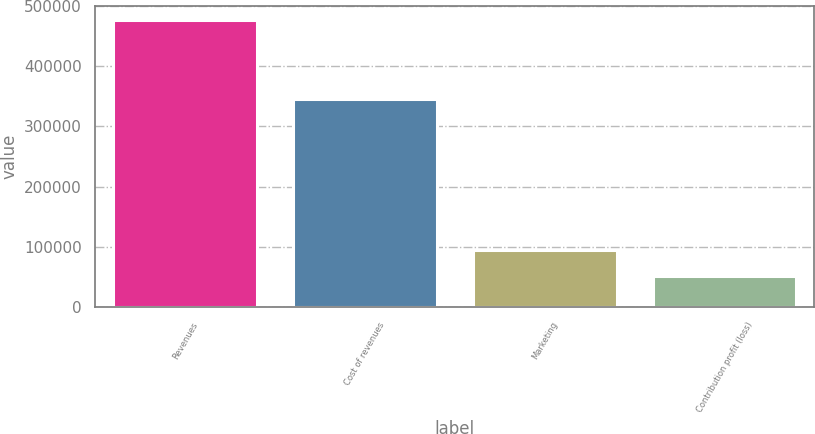<chart> <loc_0><loc_0><loc_500><loc_500><bar_chart><fcel>Revenues<fcel>Cost of revenues<fcel>Marketing<fcel>Contribution profit (loss)<nl><fcel>476334<fcel>345026<fcel>94532.4<fcel>52110<nl></chart> 